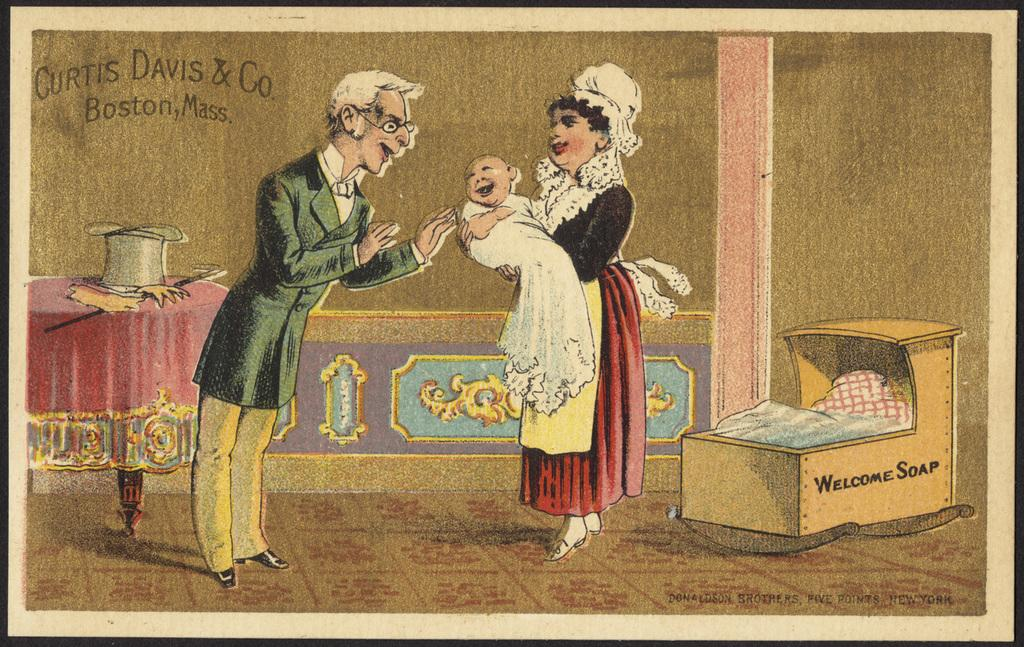What is present in the image that contains visuals and information? There is a poster in the image that contains images and text. Can you describe the images on the poster? The provided facts do not specify the content of the images on the poster. What type of information can be found on the poster? The poster contains text, which suggests it conveys some form of information or message. Where is the lunchroom located in the image? There is no mention of a lunchroom in the provided facts, so it cannot be located in the image. 